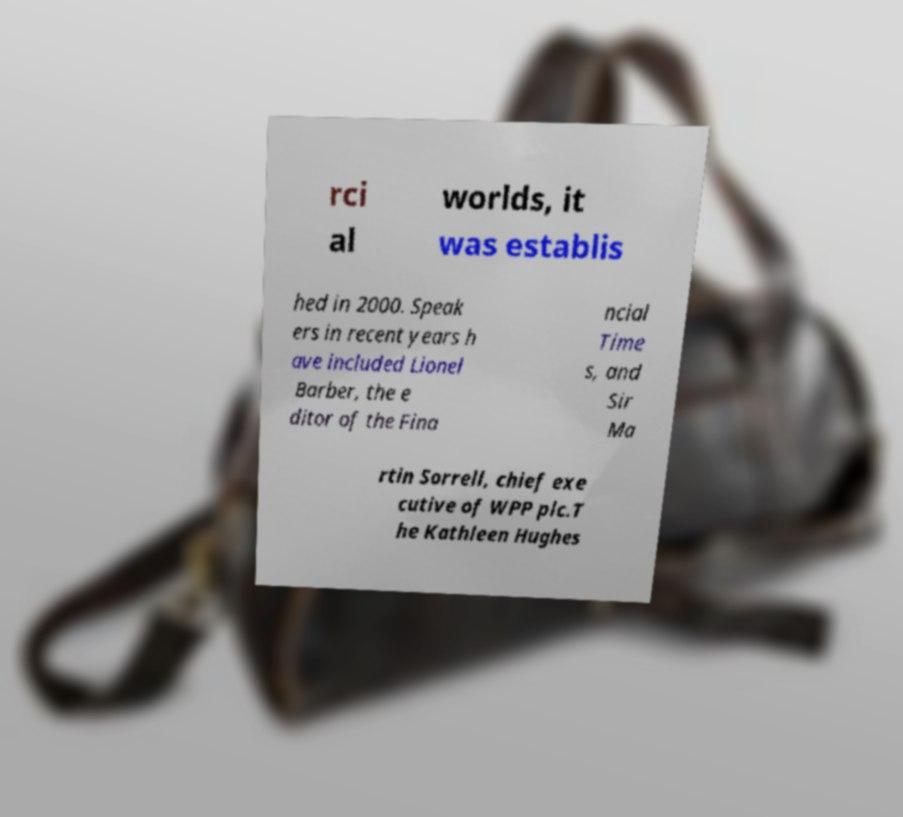I need the written content from this picture converted into text. Can you do that? rci al worlds, it was establis hed in 2000. Speak ers in recent years h ave included Lionel Barber, the e ditor of the Fina ncial Time s, and Sir Ma rtin Sorrell, chief exe cutive of WPP plc.T he Kathleen Hughes 